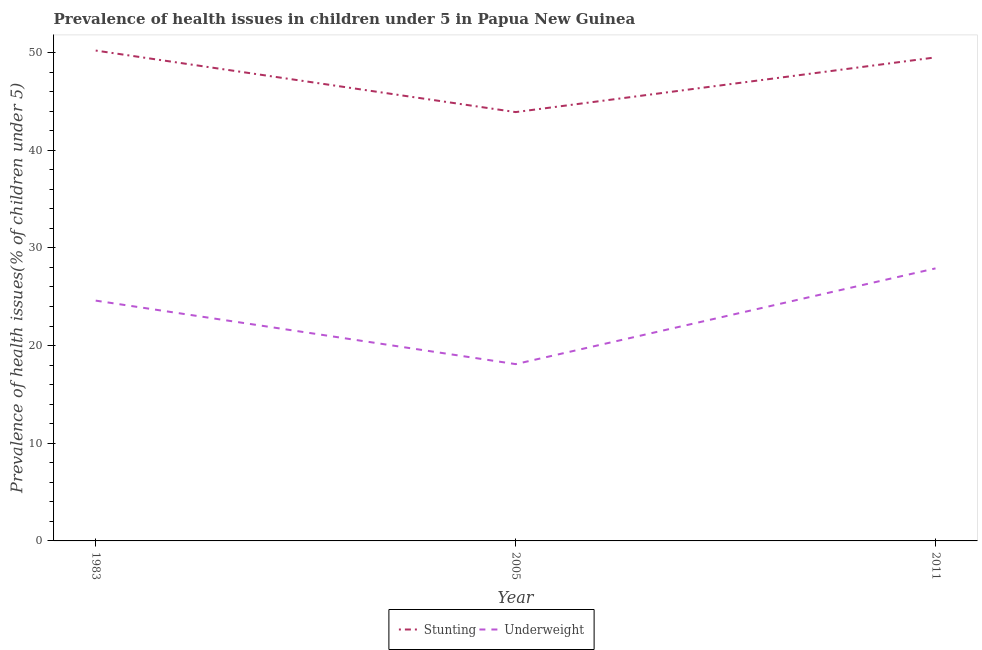How many different coloured lines are there?
Your answer should be very brief. 2. Is the number of lines equal to the number of legend labels?
Give a very brief answer. Yes. What is the percentage of stunted children in 1983?
Your response must be concise. 50.2. Across all years, what is the maximum percentage of underweight children?
Offer a very short reply. 27.9. Across all years, what is the minimum percentage of stunted children?
Make the answer very short. 43.9. In which year was the percentage of underweight children minimum?
Your answer should be compact. 2005. What is the total percentage of underweight children in the graph?
Offer a very short reply. 70.6. What is the difference between the percentage of stunted children in 2005 and that in 2011?
Keep it short and to the point. -5.6. What is the difference between the percentage of stunted children in 2005 and the percentage of underweight children in 1983?
Your answer should be very brief. 19.3. What is the average percentage of underweight children per year?
Ensure brevity in your answer.  23.53. In the year 2011, what is the difference between the percentage of stunted children and percentage of underweight children?
Give a very brief answer. 21.6. What is the ratio of the percentage of stunted children in 1983 to that in 2011?
Provide a succinct answer. 1.01. What is the difference between the highest and the second highest percentage of underweight children?
Your answer should be very brief. 3.3. What is the difference between the highest and the lowest percentage of stunted children?
Offer a very short reply. 6.3. In how many years, is the percentage of underweight children greater than the average percentage of underweight children taken over all years?
Give a very brief answer. 2. Is the percentage of underweight children strictly less than the percentage of stunted children over the years?
Your answer should be very brief. Yes. How many lines are there?
Your answer should be very brief. 2. How many years are there in the graph?
Your response must be concise. 3. What is the difference between two consecutive major ticks on the Y-axis?
Give a very brief answer. 10. Does the graph contain grids?
Provide a short and direct response. No. How many legend labels are there?
Provide a short and direct response. 2. How are the legend labels stacked?
Your answer should be very brief. Horizontal. What is the title of the graph?
Your answer should be compact. Prevalence of health issues in children under 5 in Papua New Guinea. Does "Services" appear as one of the legend labels in the graph?
Offer a very short reply. No. What is the label or title of the X-axis?
Ensure brevity in your answer.  Year. What is the label or title of the Y-axis?
Provide a succinct answer. Prevalence of health issues(% of children under 5). What is the Prevalence of health issues(% of children under 5) of Stunting in 1983?
Provide a succinct answer. 50.2. What is the Prevalence of health issues(% of children under 5) of Underweight in 1983?
Give a very brief answer. 24.6. What is the Prevalence of health issues(% of children under 5) in Stunting in 2005?
Provide a short and direct response. 43.9. What is the Prevalence of health issues(% of children under 5) in Underweight in 2005?
Give a very brief answer. 18.1. What is the Prevalence of health issues(% of children under 5) in Stunting in 2011?
Your response must be concise. 49.5. What is the Prevalence of health issues(% of children under 5) of Underweight in 2011?
Offer a terse response. 27.9. Across all years, what is the maximum Prevalence of health issues(% of children under 5) of Stunting?
Ensure brevity in your answer.  50.2. Across all years, what is the maximum Prevalence of health issues(% of children under 5) of Underweight?
Provide a succinct answer. 27.9. Across all years, what is the minimum Prevalence of health issues(% of children under 5) in Stunting?
Make the answer very short. 43.9. Across all years, what is the minimum Prevalence of health issues(% of children under 5) of Underweight?
Provide a succinct answer. 18.1. What is the total Prevalence of health issues(% of children under 5) in Stunting in the graph?
Give a very brief answer. 143.6. What is the total Prevalence of health issues(% of children under 5) in Underweight in the graph?
Offer a terse response. 70.6. What is the difference between the Prevalence of health issues(% of children under 5) of Underweight in 2005 and that in 2011?
Offer a very short reply. -9.8. What is the difference between the Prevalence of health issues(% of children under 5) of Stunting in 1983 and the Prevalence of health issues(% of children under 5) of Underweight in 2005?
Give a very brief answer. 32.1. What is the difference between the Prevalence of health issues(% of children under 5) in Stunting in 1983 and the Prevalence of health issues(% of children under 5) in Underweight in 2011?
Keep it short and to the point. 22.3. What is the difference between the Prevalence of health issues(% of children under 5) of Stunting in 2005 and the Prevalence of health issues(% of children under 5) of Underweight in 2011?
Keep it short and to the point. 16. What is the average Prevalence of health issues(% of children under 5) in Stunting per year?
Provide a short and direct response. 47.87. What is the average Prevalence of health issues(% of children under 5) in Underweight per year?
Your answer should be very brief. 23.53. In the year 1983, what is the difference between the Prevalence of health issues(% of children under 5) in Stunting and Prevalence of health issues(% of children under 5) in Underweight?
Provide a short and direct response. 25.6. In the year 2005, what is the difference between the Prevalence of health issues(% of children under 5) in Stunting and Prevalence of health issues(% of children under 5) in Underweight?
Give a very brief answer. 25.8. In the year 2011, what is the difference between the Prevalence of health issues(% of children under 5) of Stunting and Prevalence of health issues(% of children under 5) of Underweight?
Your answer should be compact. 21.6. What is the ratio of the Prevalence of health issues(% of children under 5) in Stunting in 1983 to that in 2005?
Offer a terse response. 1.14. What is the ratio of the Prevalence of health issues(% of children under 5) in Underweight in 1983 to that in 2005?
Keep it short and to the point. 1.36. What is the ratio of the Prevalence of health issues(% of children under 5) of Stunting in 1983 to that in 2011?
Your answer should be very brief. 1.01. What is the ratio of the Prevalence of health issues(% of children under 5) in Underweight in 1983 to that in 2011?
Offer a very short reply. 0.88. What is the ratio of the Prevalence of health issues(% of children under 5) in Stunting in 2005 to that in 2011?
Offer a terse response. 0.89. What is the ratio of the Prevalence of health issues(% of children under 5) of Underweight in 2005 to that in 2011?
Offer a terse response. 0.65. What is the difference between the highest and the second highest Prevalence of health issues(% of children under 5) of Stunting?
Make the answer very short. 0.7. What is the difference between the highest and the second highest Prevalence of health issues(% of children under 5) in Underweight?
Give a very brief answer. 3.3. 